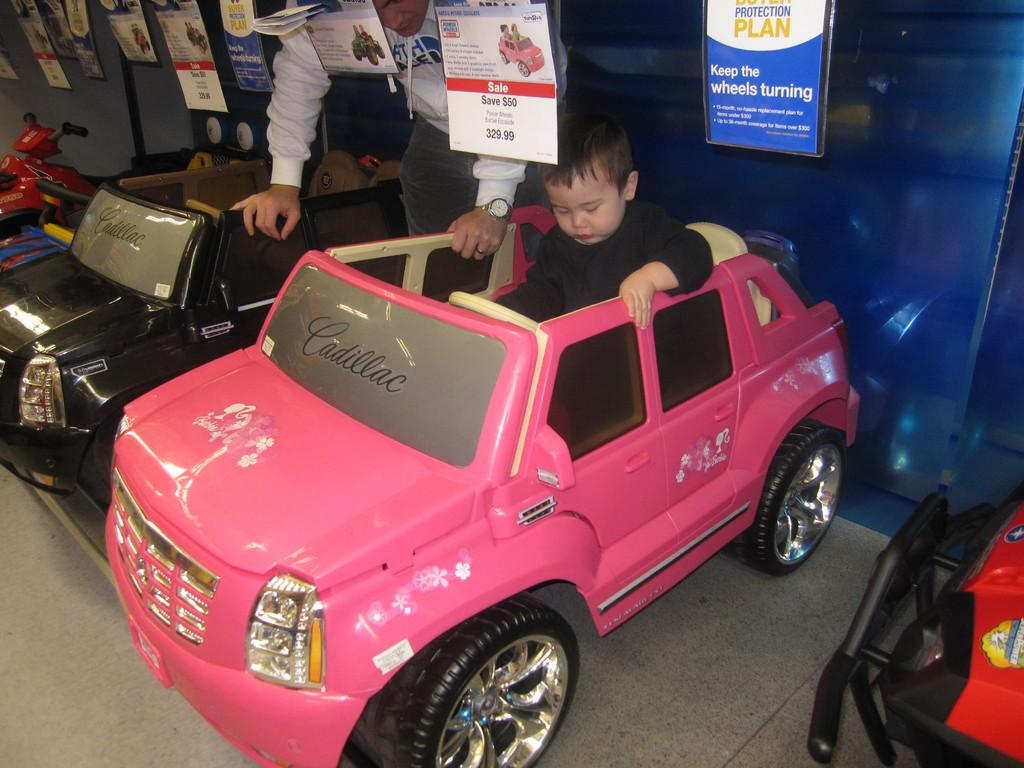What type of objects are in the image? There are toy vehicles in the image. What is the boy in the image doing? The boy is sitting in one of the toy vehicles. Can you describe the person standing behind the vehicles? There is a person standing behind the vehicles. What decorative elements can be seen in the image? There are banners visible in the image. What is visible in the background of the image? There is a wall in the background of the image. What type of chicken is the boy holding in the image? There is no chicken present in the image; the boy is sitting in a toy vehicle. How many hens can be seen on the wall in the image? There are no hens visible on the wall in the image; there is only a wall in the background. 